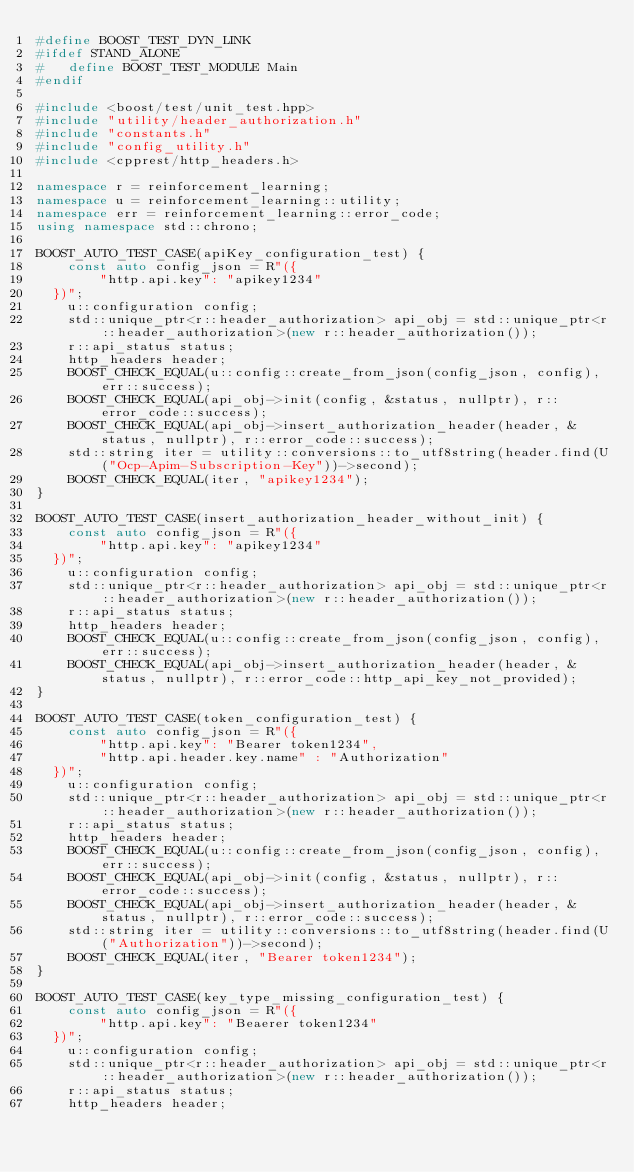<code> <loc_0><loc_0><loc_500><loc_500><_C++_>#define BOOST_TEST_DYN_LINK
#ifdef STAND_ALONE
#   define BOOST_TEST_MODULE Main
#endif

#include <boost/test/unit_test.hpp>
#include "utility/header_authorization.h"
#include "constants.h"
#include "config_utility.h"
#include <cpprest/http_headers.h>

namespace r = reinforcement_learning;
namespace u = reinforcement_learning::utility;
namespace err = reinforcement_learning::error_code;
using namespace std::chrono;

BOOST_AUTO_TEST_CASE(apiKey_configuration_test) {
    const auto config_json = R"({
        "http.api.key": "apikey1234"
  })";
    u::configuration config;
    std::unique_ptr<r::header_authorization> api_obj = std::unique_ptr<r::header_authorization>(new r::header_authorization());
    r::api_status status;
    http_headers header;
    BOOST_CHECK_EQUAL(u::config::create_from_json(config_json, config), err::success);
    BOOST_CHECK_EQUAL(api_obj->init(config, &status, nullptr), r::error_code::success);
    BOOST_CHECK_EQUAL(api_obj->insert_authorization_header(header, &status, nullptr), r::error_code::success);
    std::string iter = utility::conversions::to_utf8string(header.find(U("Ocp-Apim-Subscription-Key"))->second);
    BOOST_CHECK_EQUAL(iter, "apikey1234");
}

BOOST_AUTO_TEST_CASE(insert_authorization_header_without_init) {
    const auto config_json = R"({
        "http.api.key": "apikey1234"
  })";
    u::configuration config;
    std::unique_ptr<r::header_authorization> api_obj = std::unique_ptr<r::header_authorization>(new r::header_authorization());
    r::api_status status;
    http_headers header;
    BOOST_CHECK_EQUAL(u::config::create_from_json(config_json, config), err::success);
    BOOST_CHECK_EQUAL(api_obj->insert_authorization_header(header, &status, nullptr), r::error_code::http_api_key_not_provided);
}

BOOST_AUTO_TEST_CASE(token_configuration_test) {
    const auto config_json = R"({
        "http.api.key": "Bearer token1234",
        "http.api.header.key.name" : "Authorization"
  })";
    u::configuration config;
    std::unique_ptr<r::header_authorization> api_obj = std::unique_ptr<r::header_authorization>(new r::header_authorization());
    r::api_status status;
    http_headers header;
    BOOST_CHECK_EQUAL(u::config::create_from_json(config_json, config), err::success);
    BOOST_CHECK_EQUAL(api_obj->init(config, &status, nullptr), r::error_code::success);
    BOOST_CHECK_EQUAL(api_obj->insert_authorization_header(header, &status, nullptr), r::error_code::success);
    std::string iter = utility::conversions::to_utf8string(header.find(U("Authorization"))->second);
    BOOST_CHECK_EQUAL(iter, "Bearer token1234");
}

BOOST_AUTO_TEST_CASE(key_type_missing_configuration_test) {
    const auto config_json = R"({
        "http.api.key": "Beaerer token1234"
  })";
    u::configuration config;
    std::unique_ptr<r::header_authorization> api_obj = std::unique_ptr<r::header_authorization>(new r::header_authorization());
    r::api_status status;
    http_headers header;</code> 